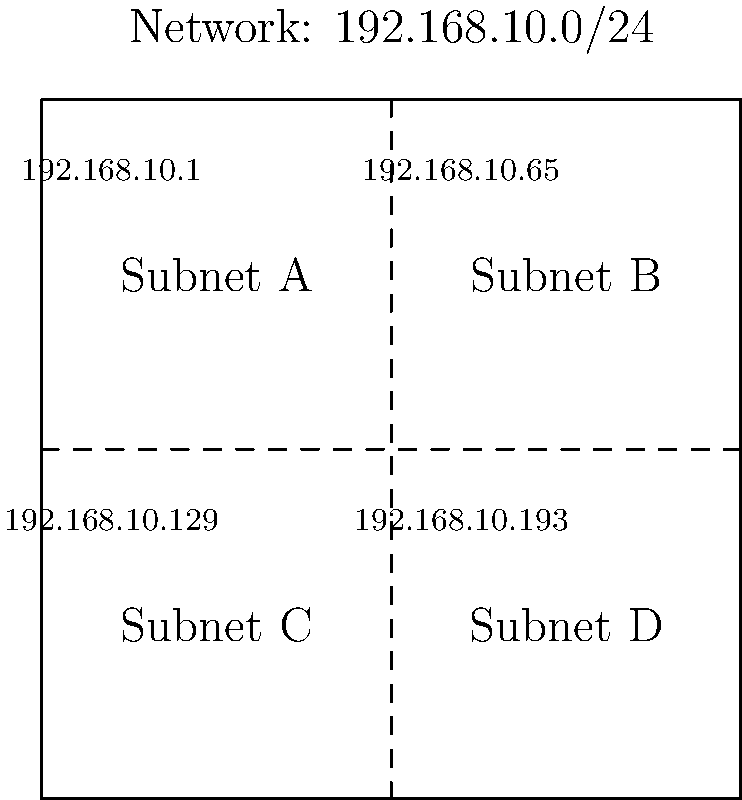Given the network diagram showing a 192.168.10.0/24 network divided into four equal subnets, what is the subnet mask for each individual subnet, and how many usable host addresses are available in each subnet? To solve this problem, let's follow these steps:

1. Understand the given network:
   - The main network is 192.168.10.0/24
   - It's divided into four equal subnets

2. Calculate the new subnet mask:
   - The original /24 mask uses 24 bits for the network portion
   - To create 4 subnets, we need 2 additional bits (2^2 = 4)
   - The new subnet mask will be /26 (24 + 2 = 26)

3. Convert /26 to decimal notation:
   - /26 means the first 26 bits are 1's, and the rest are 0's
   - In binary: 11111111.11111111.11111111.11000000
   - In decimal: 255.255.255.192

4. Calculate usable host addresses:
   - Total addresses in each subnet: 2^(32-26) = 2^6 = 64
   - Usable addresses: 64 - 2 = 62 (subtract network and broadcast addresses)

Therefore, the subnet mask for each individual subnet is 255.255.255.192 (/26), and there are 62 usable host addresses in each subnet.
Answer: 255.255.255.192 (/26); 62 usable hosts 